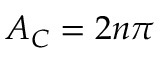Convert formula to latex. <formula><loc_0><loc_0><loc_500><loc_500>A _ { C } = 2 n \pi</formula> 